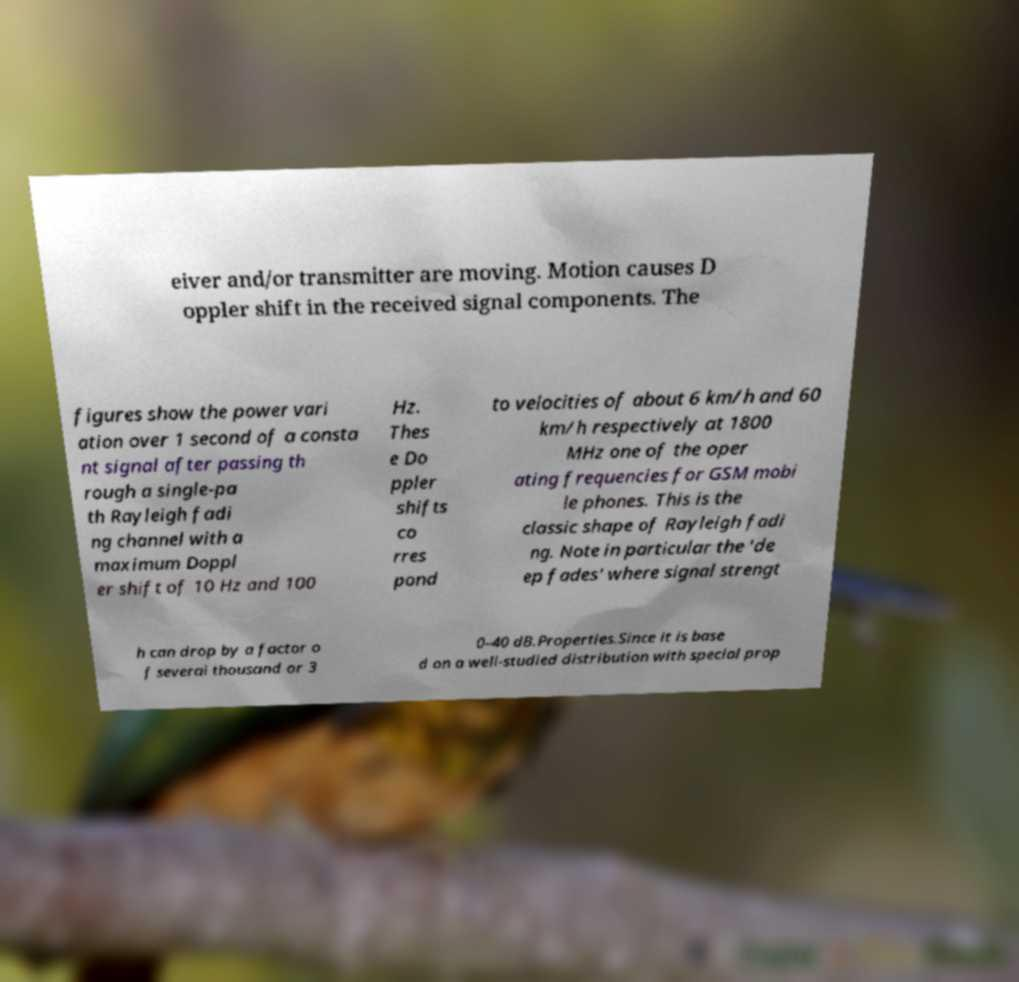Please identify and transcribe the text found in this image. eiver and/or transmitter are moving. Motion causes D oppler shift in the received signal components. The figures show the power vari ation over 1 second of a consta nt signal after passing th rough a single-pa th Rayleigh fadi ng channel with a maximum Doppl er shift of 10 Hz and 100 Hz. Thes e Do ppler shifts co rres pond to velocities of about 6 km/h and 60 km/h respectively at 1800 MHz one of the oper ating frequencies for GSM mobi le phones. This is the classic shape of Rayleigh fadi ng. Note in particular the 'de ep fades' where signal strengt h can drop by a factor o f several thousand or 3 0–40 dB.Properties.Since it is base d on a well-studied distribution with special prop 